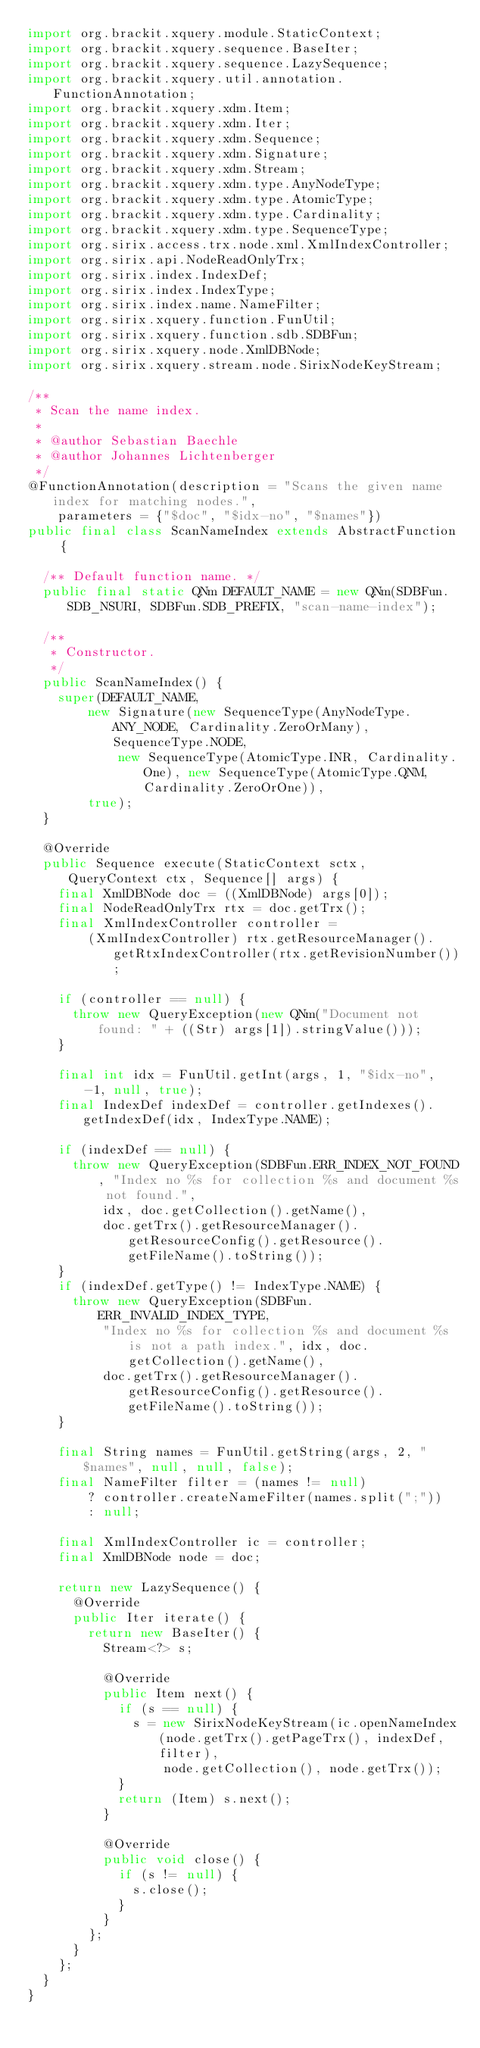Convert code to text. <code><loc_0><loc_0><loc_500><loc_500><_Java_>import org.brackit.xquery.module.StaticContext;
import org.brackit.xquery.sequence.BaseIter;
import org.brackit.xquery.sequence.LazySequence;
import org.brackit.xquery.util.annotation.FunctionAnnotation;
import org.brackit.xquery.xdm.Item;
import org.brackit.xquery.xdm.Iter;
import org.brackit.xquery.xdm.Sequence;
import org.brackit.xquery.xdm.Signature;
import org.brackit.xquery.xdm.Stream;
import org.brackit.xquery.xdm.type.AnyNodeType;
import org.brackit.xquery.xdm.type.AtomicType;
import org.brackit.xquery.xdm.type.Cardinality;
import org.brackit.xquery.xdm.type.SequenceType;
import org.sirix.access.trx.node.xml.XmlIndexController;
import org.sirix.api.NodeReadOnlyTrx;
import org.sirix.index.IndexDef;
import org.sirix.index.IndexType;
import org.sirix.index.name.NameFilter;
import org.sirix.xquery.function.FunUtil;
import org.sirix.xquery.function.sdb.SDBFun;
import org.sirix.xquery.node.XmlDBNode;
import org.sirix.xquery.stream.node.SirixNodeKeyStream;

/**
 * Scan the name index.
 *
 * @author Sebastian Baechle
 * @author Johannes Lichtenberger
 */
@FunctionAnnotation(description = "Scans the given name index for matching nodes.",
    parameters = {"$doc", "$idx-no", "$names"})
public final class ScanNameIndex extends AbstractFunction {

  /** Default function name. */
  public final static QNm DEFAULT_NAME = new QNm(SDBFun.SDB_NSURI, SDBFun.SDB_PREFIX, "scan-name-index");

  /**
   * Constructor.
   */
  public ScanNameIndex() {
    super(DEFAULT_NAME,
        new Signature(new SequenceType(AnyNodeType.ANY_NODE, Cardinality.ZeroOrMany), SequenceType.NODE,
            new SequenceType(AtomicType.INR, Cardinality.One), new SequenceType(AtomicType.QNM, Cardinality.ZeroOrOne)),
        true);
  }

  @Override
  public Sequence execute(StaticContext sctx, QueryContext ctx, Sequence[] args) {
    final XmlDBNode doc = ((XmlDBNode) args[0]);
    final NodeReadOnlyTrx rtx = doc.getTrx();
    final XmlIndexController controller =
        (XmlIndexController) rtx.getResourceManager().getRtxIndexController(rtx.getRevisionNumber());

    if (controller == null) {
      throw new QueryException(new QNm("Document not found: " + ((Str) args[1]).stringValue()));
    }

    final int idx = FunUtil.getInt(args, 1, "$idx-no", -1, null, true);
    final IndexDef indexDef = controller.getIndexes().getIndexDef(idx, IndexType.NAME);

    if (indexDef == null) {
      throw new QueryException(SDBFun.ERR_INDEX_NOT_FOUND, "Index no %s for collection %s and document %s not found.",
          idx, doc.getCollection().getName(),
          doc.getTrx().getResourceManager().getResourceConfig().getResource().getFileName().toString());
    }
    if (indexDef.getType() != IndexType.NAME) {
      throw new QueryException(SDBFun.ERR_INVALID_INDEX_TYPE,
          "Index no %s for collection %s and document %s is not a path index.", idx, doc.getCollection().getName(),
          doc.getTrx().getResourceManager().getResourceConfig().getResource().getFileName().toString());
    }

    final String names = FunUtil.getString(args, 2, "$names", null, null, false);
    final NameFilter filter = (names != null)
        ? controller.createNameFilter(names.split(";"))
        : null;

    final XmlIndexController ic = controller;
    final XmlDBNode node = doc;

    return new LazySequence() {
      @Override
      public Iter iterate() {
        return new BaseIter() {
          Stream<?> s;

          @Override
          public Item next() {
            if (s == null) {
              s = new SirixNodeKeyStream(ic.openNameIndex(node.getTrx().getPageTrx(), indexDef, filter),
                  node.getCollection(), node.getTrx());
            }
            return (Item) s.next();
          }

          @Override
          public void close() {
            if (s != null) {
              s.close();
            }
          }
        };
      }
    };
  }
}
</code> 